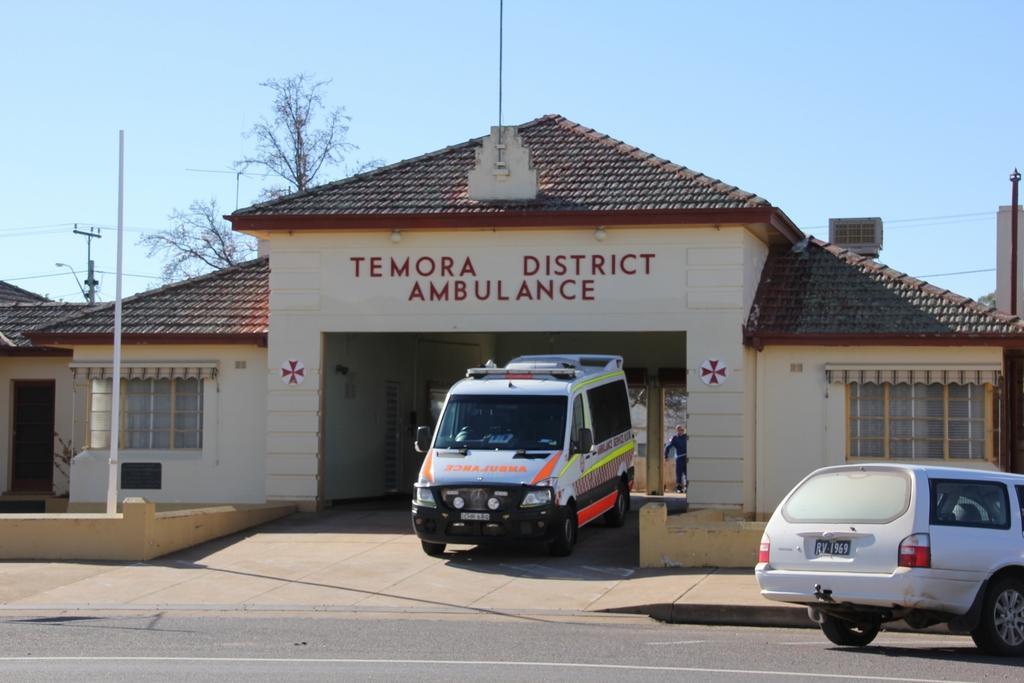Describe this image in one or two sentences. In this image there are some houses and some vehicles, on the left side there are two poles and wires and trees. On the top of the image there is sky, at the bottom there is road. In the center there is one person. 